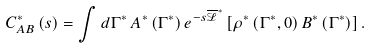<formula> <loc_0><loc_0><loc_500><loc_500>C _ { A B } ^ { \ast } \left ( s \right ) = \int d \Gamma ^ { \ast } \, A ^ { \ast } \left ( \Gamma ^ { \ast } \right ) e ^ { - s \overline { \mathcal { L } } ^ { \ast } } \left [ \rho ^ { \ast } \left ( \Gamma ^ { \ast } , 0 \right ) B ^ { \ast } \left ( \Gamma ^ { \ast } \right ) \right ] .</formula> 